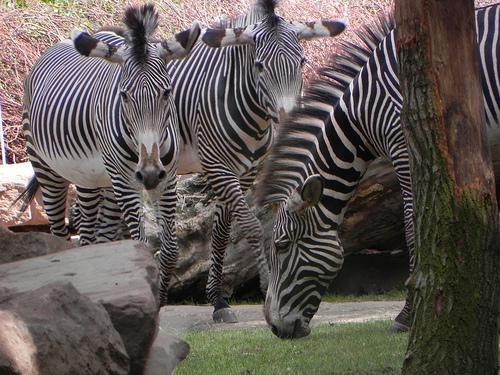How many zebra are there?
Give a very brief answer. 3. 